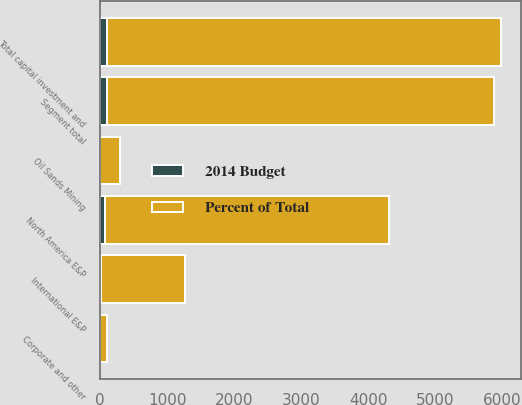<chart> <loc_0><loc_0><loc_500><loc_500><stacked_bar_chart><ecel><fcel>North America E&P<fcel>International E&P<fcel>Oil Sands Mining<fcel>Segment total<fcel>Corporate and other<fcel>Total capital investment and<nl><fcel>Percent of Total<fcel>4241<fcel>1242<fcel>294<fcel>5777<fcel>105<fcel>5882<nl><fcel>2014 Budget<fcel>72<fcel>21<fcel>5<fcel>98<fcel>2<fcel>100<nl></chart> 